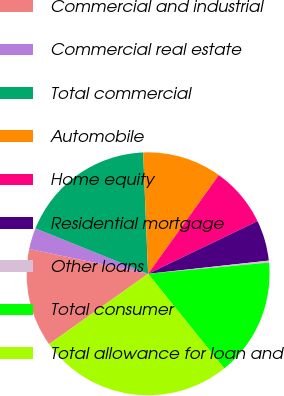Convert chart to OTSL. <chart><loc_0><loc_0><loc_500><loc_500><pie_chart><fcel>Commercial and industrial<fcel>Commercial real estate<fcel>Total commercial<fcel>Automobile<fcel>Home equity<fcel>Residential mortgage<fcel>Other loans<fcel>Total consumer<fcel>Total allowance for loan and<nl><fcel>13.11%<fcel>2.83%<fcel>18.25%<fcel>10.54%<fcel>7.97%<fcel>5.4%<fcel>0.26%<fcel>15.68%<fcel>25.96%<nl></chart> 